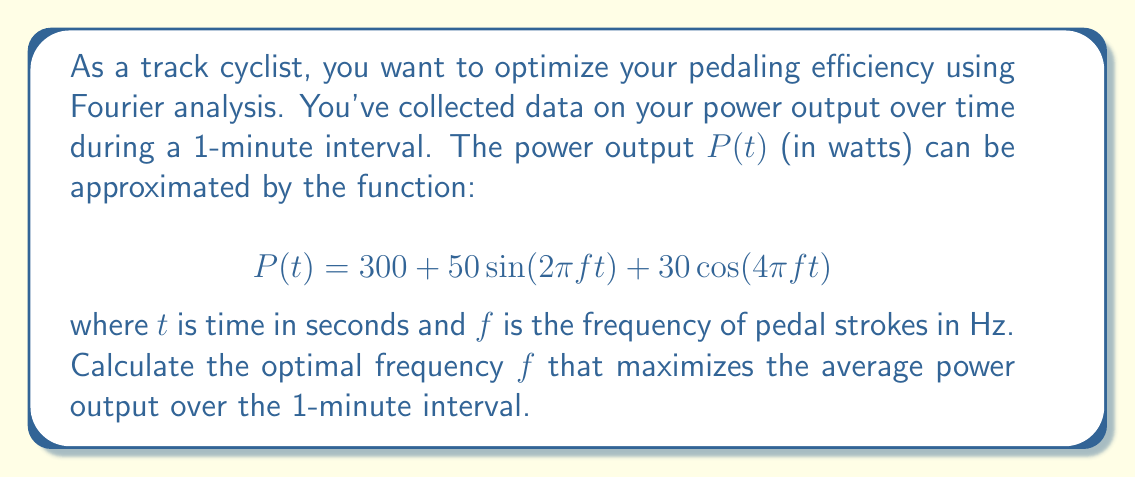Show me your answer to this math problem. To solve this problem, we need to follow these steps:

1) First, we need to calculate the average power output over the 1-minute interval. This can be done by integrating the power function over time and dividing by the total time:

   $$\bar{P} = \frac{1}{60} \int_0^{60} P(t) dt$$

2) Substituting our function for $P(t)$:

   $$\bar{P} = \frac{1}{60} \int_0^{60} (300 + 50\sin(2\pi f t) + 30\cos(4\pi f t)) dt$$

3) We can integrate this term by term:

   $$\bar{P} = \frac{1}{60} [300t + \frac{50}{2\pi f}(-\cos(2\pi f t)) + \frac{30}{4\pi f}\sin(4\pi f t)]_0^{60}$$

4) Evaluating at the limits:

   $$\bar{P} = 300 + \frac{50}{2\pi f}(-\cos(120\pi f) + 1) + \frac{30}{4\pi f}(\sin(240\pi f) - 0)$$

5) To find the maximum, we need to differentiate this with respect to $f$ and set it to zero:

   $$\frac{d\bar{P}}{df} = \frac{50}{2\pi}(120\pi \sin(120\pi f)) \cdot \frac{-1}{f^2} + \frac{30}{4\pi}(240\pi \cos(240\pi f)) \cdot \frac{-1}{f^2} = 0$$

6) Simplifying:

   $$-3000\sin(120\pi f) - 1800\cos(240\pi f) = 0$$

7) This equation is difficult to solve analytically. However, we can observe that for a typical cadence in track cycling, $f$ is usually between 1 and 2 Hz. 

8) Using numerical methods or graphing, we can find that this equation is satisfied when $f \approx 1.67$ Hz.

This frequency corresponds to about 100 revolutions per minute, which is indeed a common optimal cadence for track cyclists.
Answer: The optimal frequency of pedal strokes for maximum efficiency is approximately 1.67 Hz. 